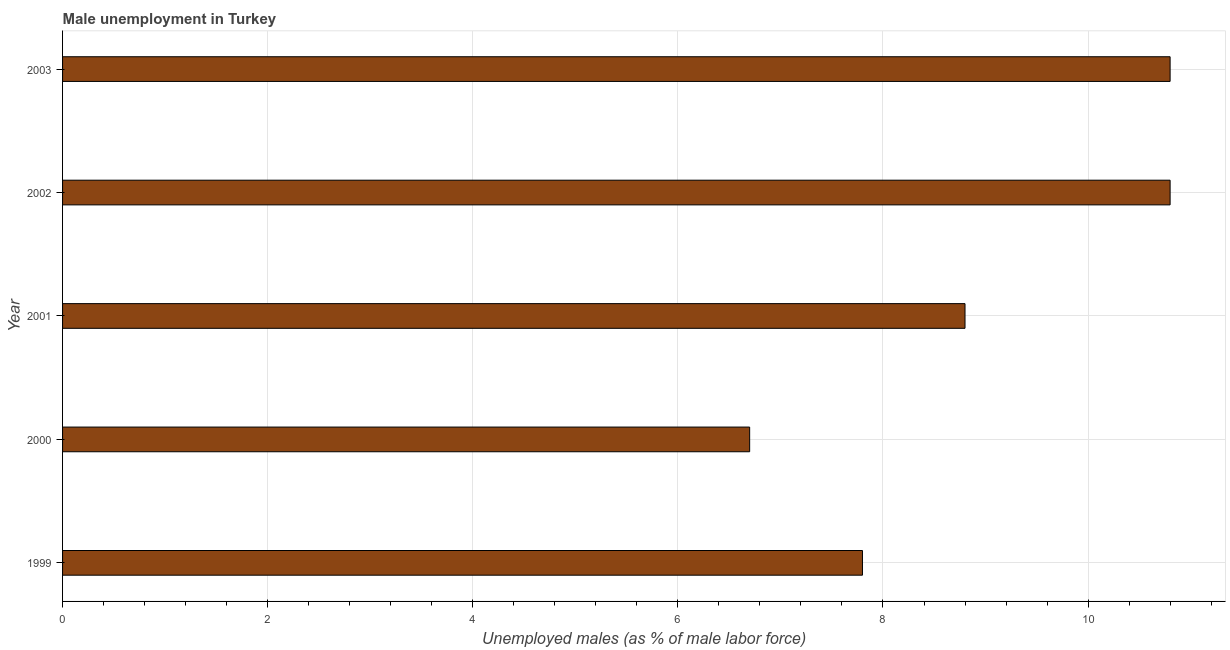Does the graph contain any zero values?
Give a very brief answer. No. What is the title of the graph?
Keep it short and to the point. Male unemployment in Turkey. What is the label or title of the X-axis?
Give a very brief answer. Unemployed males (as % of male labor force). What is the unemployed males population in 2001?
Keep it short and to the point. 8.8. Across all years, what is the maximum unemployed males population?
Ensure brevity in your answer.  10.8. Across all years, what is the minimum unemployed males population?
Offer a very short reply. 6.7. In which year was the unemployed males population minimum?
Offer a terse response. 2000. What is the sum of the unemployed males population?
Your answer should be compact. 44.9. What is the average unemployed males population per year?
Your answer should be compact. 8.98. What is the median unemployed males population?
Offer a very short reply. 8.8. In how many years, is the unemployed males population greater than 3.2 %?
Provide a succinct answer. 5. What is the ratio of the unemployed males population in 2000 to that in 2002?
Offer a terse response. 0.62. Is the unemployed males population in 2001 less than that in 2002?
Ensure brevity in your answer.  Yes. What is the difference between the highest and the second highest unemployed males population?
Offer a terse response. 0. Is the sum of the unemployed males population in 2000 and 2003 greater than the maximum unemployed males population across all years?
Keep it short and to the point. Yes. Are all the bars in the graph horizontal?
Your answer should be compact. Yes. Are the values on the major ticks of X-axis written in scientific E-notation?
Provide a succinct answer. No. What is the Unemployed males (as % of male labor force) of 1999?
Provide a short and direct response. 7.8. What is the Unemployed males (as % of male labor force) of 2000?
Give a very brief answer. 6.7. What is the Unemployed males (as % of male labor force) in 2001?
Provide a succinct answer. 8.8. What is the Unemployed males (as % of male labor force) in 2002?
Your answer should be compact. 10.8. What is the Unemployed males (as % of male labor force) in 2003?
Offer a very short reply. 10.8. What is the difference between the Unemployed males (as % of male labor force) in 1999 and 2000?
Offer a very short reply. 1.1. What is the difference between the Unemployed males (as % of male labor force) in 1999 and 2001?
Provide a succinct answer. -1. What is the difference between the Unemployed males (as % of male labor force) in 1999 and 2003?
Your answer should be very brief. -3. What is the difference between the Unemployed males (as % of male labor force) in 2000 and 2001?
Give a very brief answer. -2.1. What is the difference between the Unemployed males (as % of male labor force) in 2000 and 2002?
Keep it short and to the point. -4.1. What is the ratio of the Unemployed males (as % of male labor force) in 1999 to that in 2000?
Keep it short and to the point. 1.16. What is the ratio of the Unemployed males (as % of male labor force) in 1999 to that in 2001?
Provide a short and direct response. 0.89. What is the ratio of the Unemployed males (as % of male labor force) in 1999 to that in 2002?
Give a very brief answer. 0.72. What is the ratio of the Unemployed males (as % of male labor force) in 1999 to that in 2003?
Your answer should be very brief. 0.72. What is the ratio of the Unemployed males (as % of male labor force) in 2000 to that in 2001?
Give a very brief answer. 0.76. What is the ratio of the Unemployed males (as % of male labor force) in 2000 to that in 2002?
Your answer should be compact. 0.62. What is the ratio of the Unemployed males (as % of male labor force) in 2000 to that in 2003?
Provide a short and direct response. 0.62. What is the ratio of the Unemployed males (as % of male labor force) in 2001 to that in 2002?
Make the answer very short. 0.81. What is the ratio of the Unemployed males (as % of male labor force) in 2001 to that in 2003?
Your response must be concise. 0.81. What is the ratio of the Unemployed males (as % of male labor force) in 2002 to that in 2003?
Keep it short and to the point. 1. 